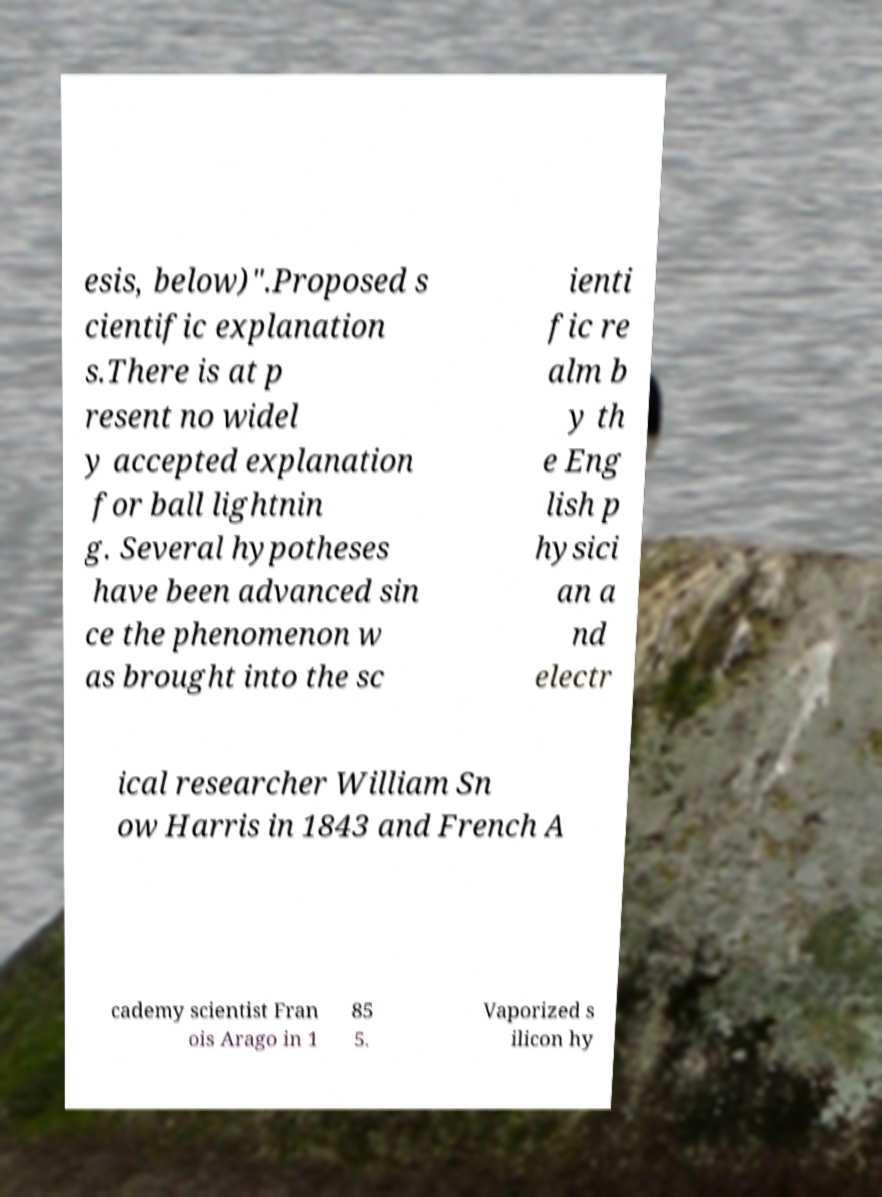Could you assist in decoding the text presented in this image and type it out clearly? esis, below)".Proposed s cientific explanation s.There is at p resent no widel y accepted explanation for ball lightnin g. Several hypotheses have been advanced sin ce the phenomenon w as brought into the sc ienti fic re alm b y th e Eng lish p hysici an a nd electr ical researcher William Sn ow Harris in 1843 and French A cademy scientist Fran ois Arago in 1 85 5. Vaporized s ilicon hy 